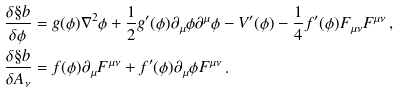<formula> <loc_0><loc_0><loc_500><loc_500>\frac { \delta \S b } { \delta \phi } & = g ( \phi ) \nabla ^ { 2 } \phi + \frac { 1 } { 2 } g ^ { \prime } ( \phi ) \partial _ { \mu } \phi \partial ^ { \mu } \phi - V ^ { \prime } ( \phi ) - \frac { 1 } { 4 } f ^ { \prime } ( \phi ) F _ { \mu \nu } F ^ { \mu \nu } \, , \\ \frac { \delta \S b } { \delta A _ { \nu } } & = f ( \phi ) \partial _ { \mu } F ^ { \mu \nu } + f ^ { \prime } ( \phi ) \partial _ { \mu } \phi F ^ { \mu \nu } \, .</formula> 